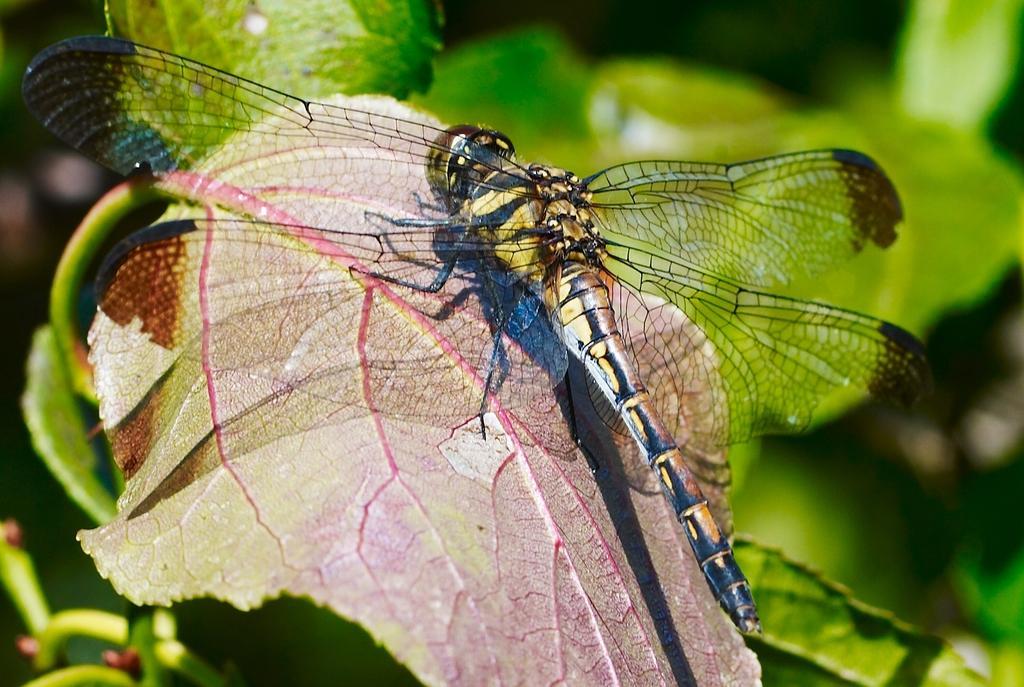Could you give a brief overview of what you see in this image? In this image, we can see an insect on the leaf, there is a blur background. 